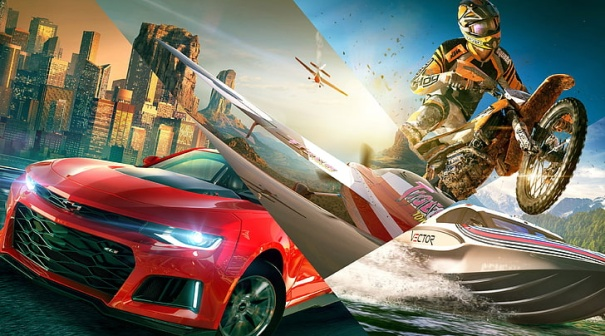Describe how the city environment might impact the actions of the vehicles and people in the image. The city environment introduces numerous elements that heighten the excitement and complexity of the actions depicted. The tightly packed buildings create a maze-like setting, requiring sharp turns and skilled navigation for the red sports car as it speeds towards its destination. For the dirt bike rider, urban obstacles such as railings, stairs, and narrow pathways provide opportunities for daring stunts and jumps. The helicopters need to maneuver carefully around skyscrapers, ensuring they don't disrupt the flow of the action below. The city's dynamic ambiance, with its mix of structures and open spaces, adds layers of challenge and thrill to the scene, making every movement within this urban playground more dramatic and engaging. Can you provide a short narrative focusing on an epic chase that involves all elements seen in the image? The adrenaline-fueled chase began with the red sports car weaving through city streets, with a daring dirt bike hot on its tail. Overhead, helicopters tracked their every move, while pedestrians gasped at the spectacle. The car veered sharply, barely missing a building as the dirt bike launched off a ramp, performing an impressive aerial maneuver. As they sped towards the outskirts, the car pushed to its limits, the sword on its hood glinting in the setting sun. The chase headed toward a river, where a surprise awaited — a speedboat ready to take the chase to the waters. The rider shifted from bike to boat in one fluid motion. Pursuers in helicopters maintained their pursuit, capturing every exhilarating moment as the chase moved from concrete jungle to water, with mountains rising in the distance. If this image was the cover of a graphic novel, what would be the novel's title and main plot? The graphic novel could be titled 'Urban Thrill: Chase through the Concrete Frontier'. The plot centers around a high-stakes chase sprawling across an entire cityscape. A skilled driver, known by the moniker Red Blade due to the signature sword on his car, finds himself on the run after uncovering a secret that can change the city's power dynamics. Hot on his heels is an elite stunt rider, Blitz, who is determined to bring Red Blade to justice for her own reasons. As they race through the labyrinthine streets and waterways of the city, avoiding aerial surveillance and overcoming countless hurdles, the duo uncovers dark truths about the city they call home. Their journey is not just about speed, but also about uncovering their interconnected destinies amid the towering skyscrapers and the shadowy figures that control the urban expanse. 